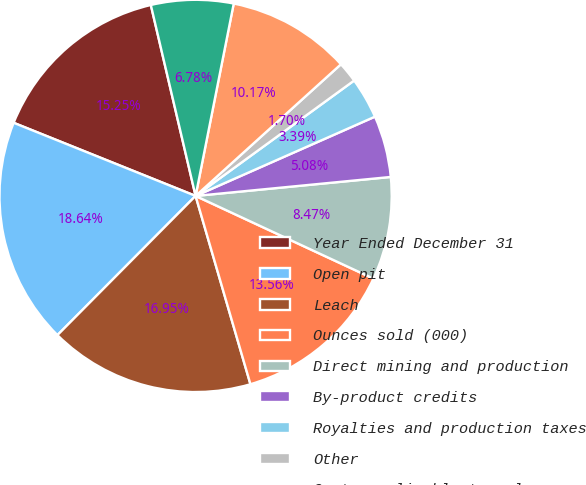Convert chart. <chart><loc_0><loc_0><loc_500><loc_500><pie_chart><fcel>Year Ended December 31<fcel>Open pit<fcel>Leach<fcel>Ounces sold (000)<fcel>Direct mining and production<fcel>By-product credits<fcel>Royalties and production taxes<fcel>Other<fcel>Costs applicable to sales<fcel>Amortization<nl><fcel>15.25%<fcel>18.64%<fcel>16.95%<fcel>13.56%<fcel>8.47%<fcel>5.08%<fcel>3.39%<fcel>1.7%<fcel>10.17%<fcel>6.78%<nl></chart> 